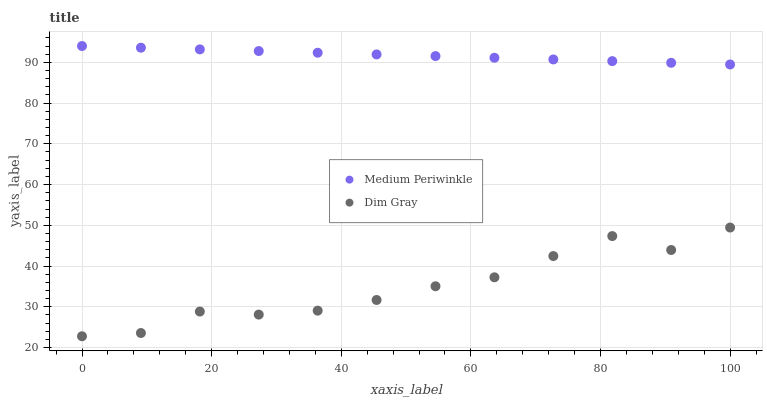Does Dim Gray have the minimum area under the curve?
Answer yes or no. Yes. Does Medium Periwinkle have the maximum area under the curve?
Answer yes or no. Yes. Does Medium Periwinkle have the minimum area under the curve?
Answer yes or no. No. Is Medium Periwinkle the smoothest?
Answer yes or no. Yes. Is Dim Gray the roughest?
Answer yes or no. Yes. Is Medium Periwinkle the roughest?
Answer yes or no. No. Does Dim Gray have the lowest value?
Answer yes or no. Yes. Does Medium Periwinkle have the lowest value?
Answer yes or no. No. Does Medium Periwinkle have the highest value?
Answer yes or no. Yes. Is Dim Gray less than Medium Periwinkle?
Answer yes or no. Yes. Is Medium Periwinkle greater than Dim Gray?
Answer yes or no. Yes. Does Dim Gray intersect Medium Periwinkle?
Answer yes or no. No. 